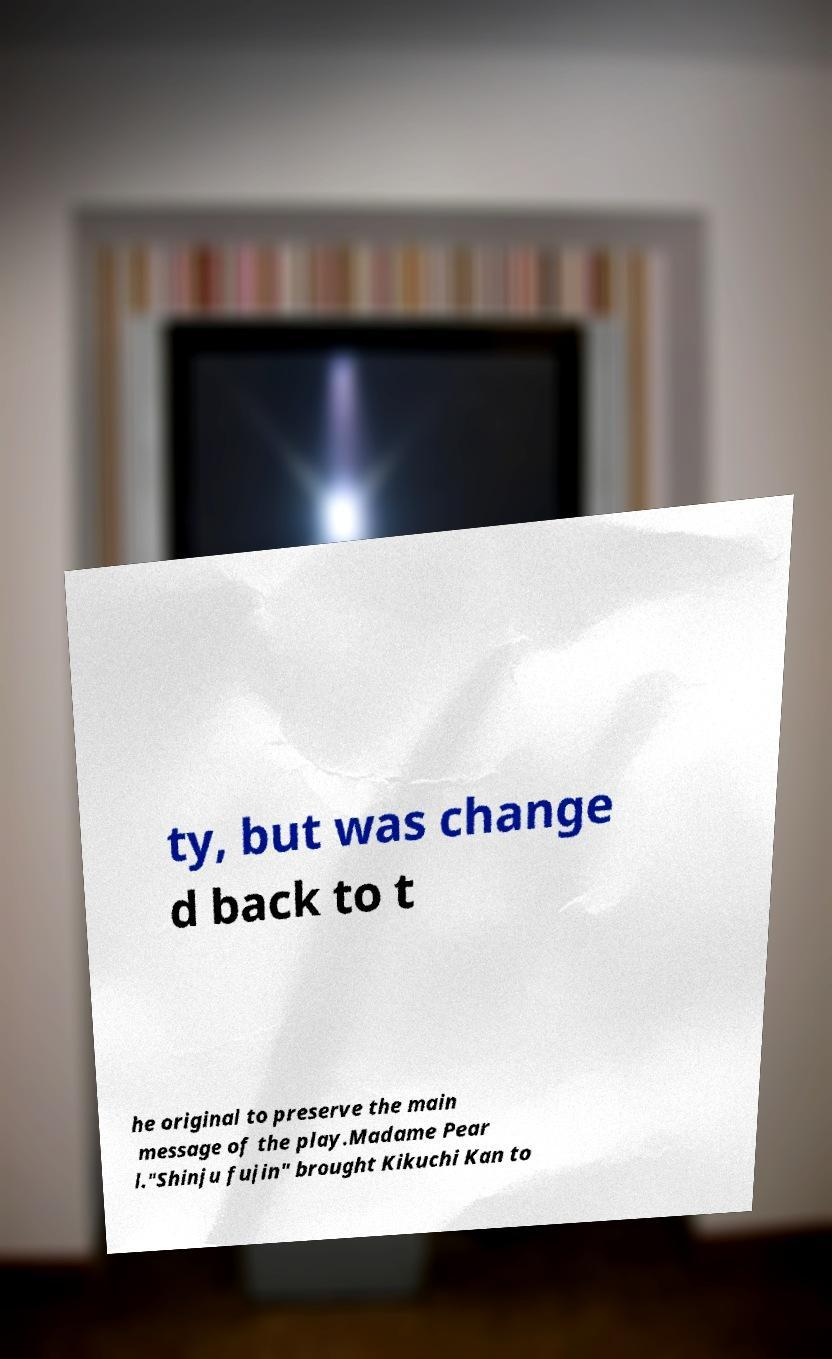Can you accurately transcribe the text from the provided image for me? ty, but was change d back to t he original to preserve the main message of the play.Madame Pear l."Shinju fujin" brought Kikuchi Kan to 